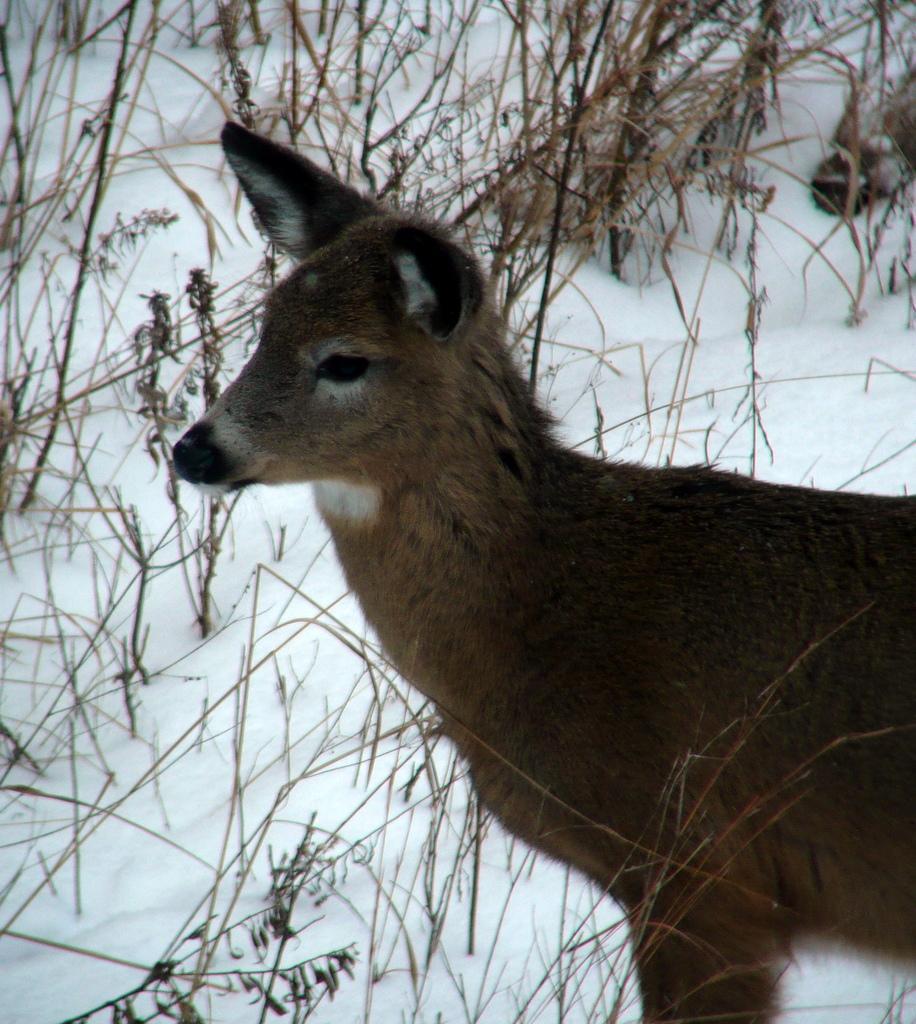Could you give a brief overview of what you see in this image? In this image we can see a white tailed deer, snow and grass. 